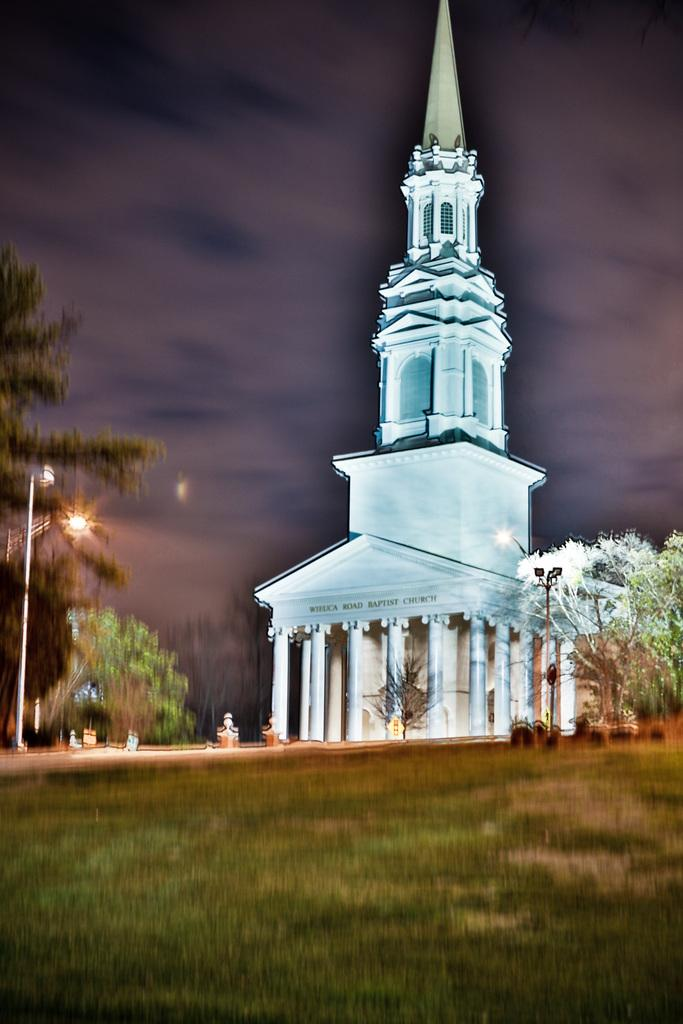What type of structure is present in the image? There is a building in the image. Where is the street light located in the image? The street light is on the left side of the image. What type of vegetation is present on the grassland in the image? There are trees on the grassland in the image. What is visible at the top of the image? The sky is visible at the top of the image. What type of lace is used to decorate the government building in the image? There is no mention of lace or a government building in the image. The image only features a building, a street light, trees, and the sky. 